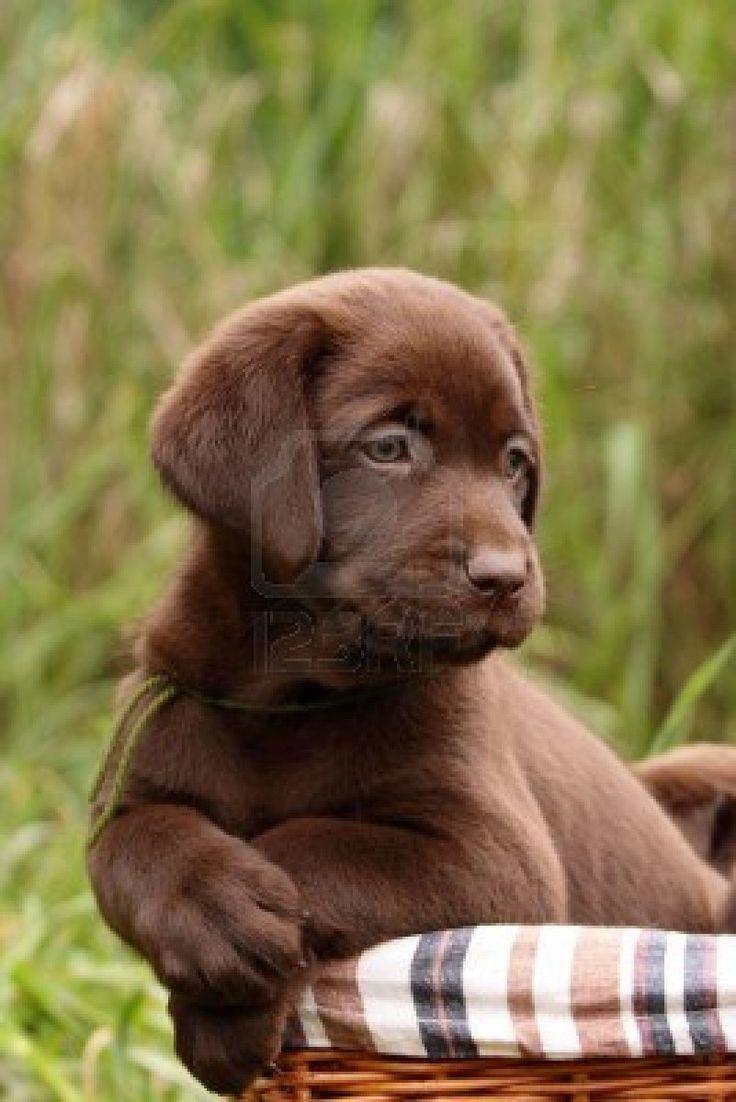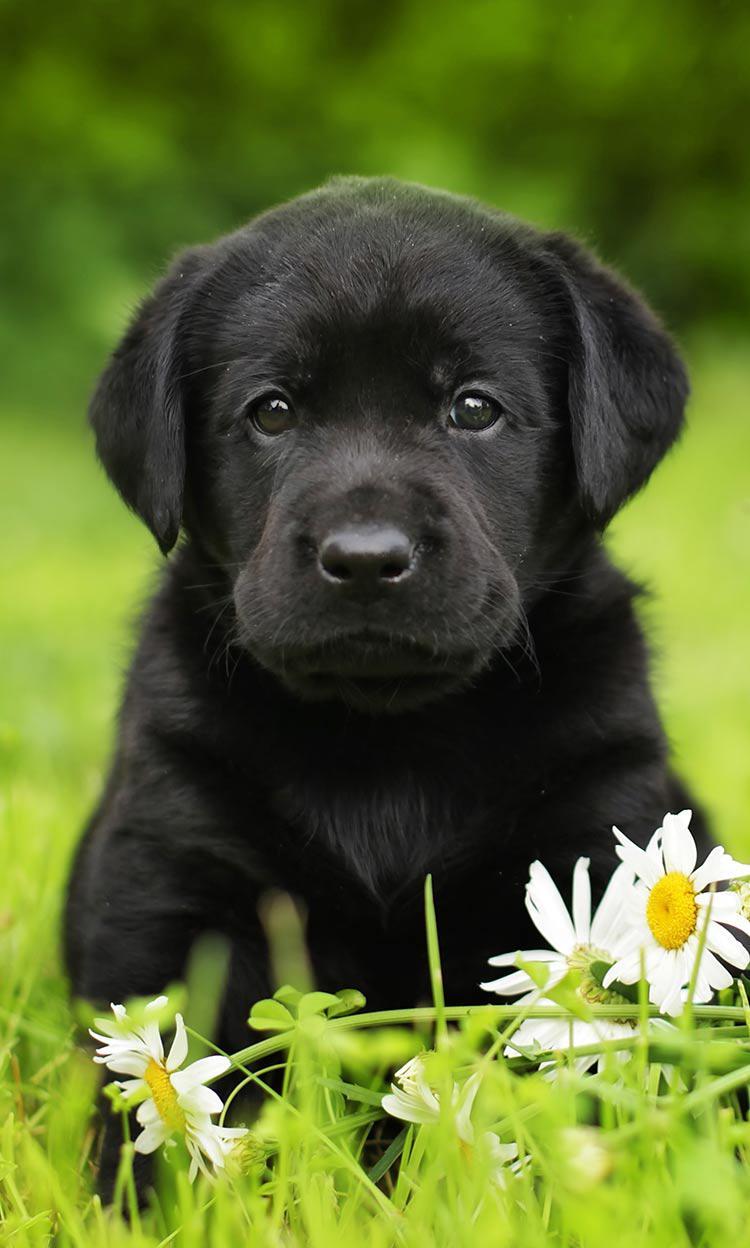The first image is the image on the left, the second image is the image on the right. Analyze the images presented: Is the assertion "A brown puppy is posed on a printed fabric surface." valid? Answer yes or no. Yes. The first image is the image on the left, the second image is the image on the right. Analyze the images presented: Is the assertion "the animal in the image on the left is in a container" valid? Answer yes or no. Yes. 